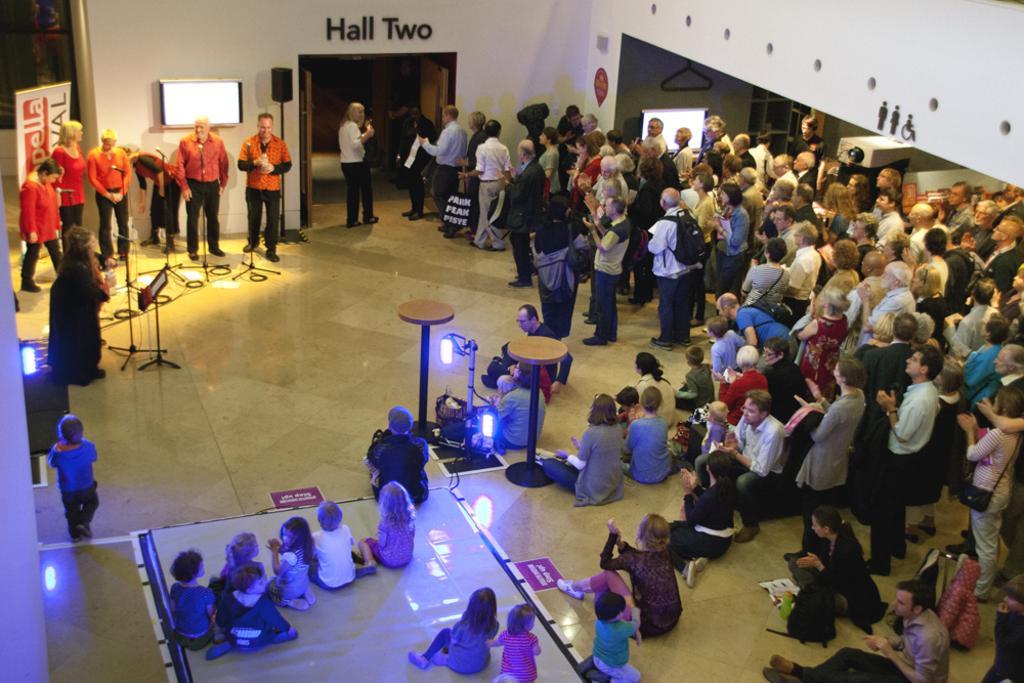Please provide a concise description of this image. In front of the image there are a few people sitting on the floor and there are a few people standing. There are tables, lamps, mike stands. In the background of the image there are televisions, board, mike and some other objects. There is an open door. There are some letters on the wall. 